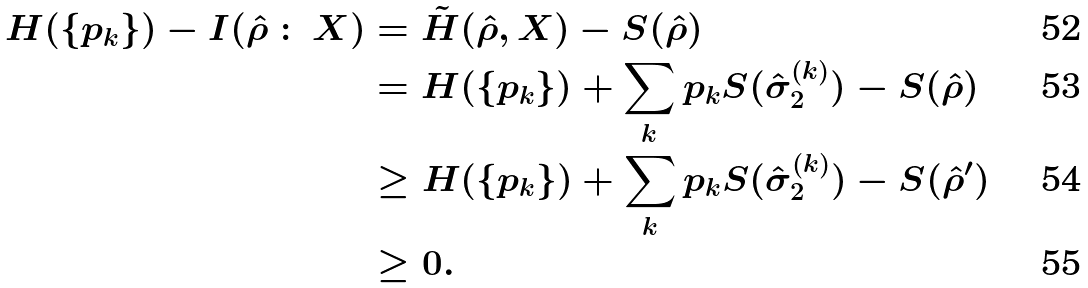Convert formula to latex. <formula><loc_0><loc_0><loc_500><loc_500>H ( \{ p _ { k } \} ) - I ( \hat { \rho } \, \colon \, X ) & = \tilde { H } ( \hat { \rho } , X ) - S ( \hat { \rho } ) \\ & = H ( \{ p _ { k } \} ) + \sum _ { k } p _ { k } S ( \hat { \sigma } _ { 2 } ^ { ( k ) } ) - S ( \hat { \rho } ) \\ & \geq H ( \{ p _ { k } \} ) + \sum _ { k } p _ { k } S ( \hat { \sigma } _ { 2 } ^ { ( k ) } ) - S ( \hat { \rho } ^ { \prime } ) \\ & \geq 0 .</formula> 